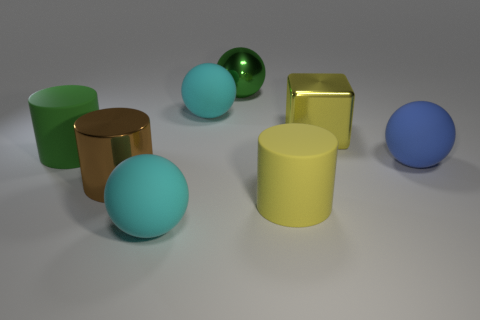What is the material of the blue thing that is the same size as the shiny ball?
Your response must be concise. Rubber. How many rubber things are large things or cyan blocks?
Provide a succinct answer. 5. What color is the large sphere that is behind the blue matte ball and in front of the green metallic ball?
Ensure brevity in your answer.  Cyan. There is a big blue ball; what number of rubber cylinders are right of it?
Your answer should be compact. 0. What is the large blue sphere made of?
Ensure brevity in your answer.  Rubber. There is a rubber ball that is in front of the large blue matte object that is to the right of the cyan thing in front of the big brown metal thing; what color is it?
Your response must be concise. Cyan. What number of metallic cubes are the same size as the green rubber cylinder?
Keep it short and to the point. 1. What is the color of the object in front of the large yellow rubber cylinder?
Provide a short and direct response. Cyan. What number of other objects are the same size as the green matte thing?
Provide a succinct answer. 7. There is a rubber ball that is both left of the big blue ball and behind the large metallic cylinder; what is its size?
Make the answer very short. Large. 